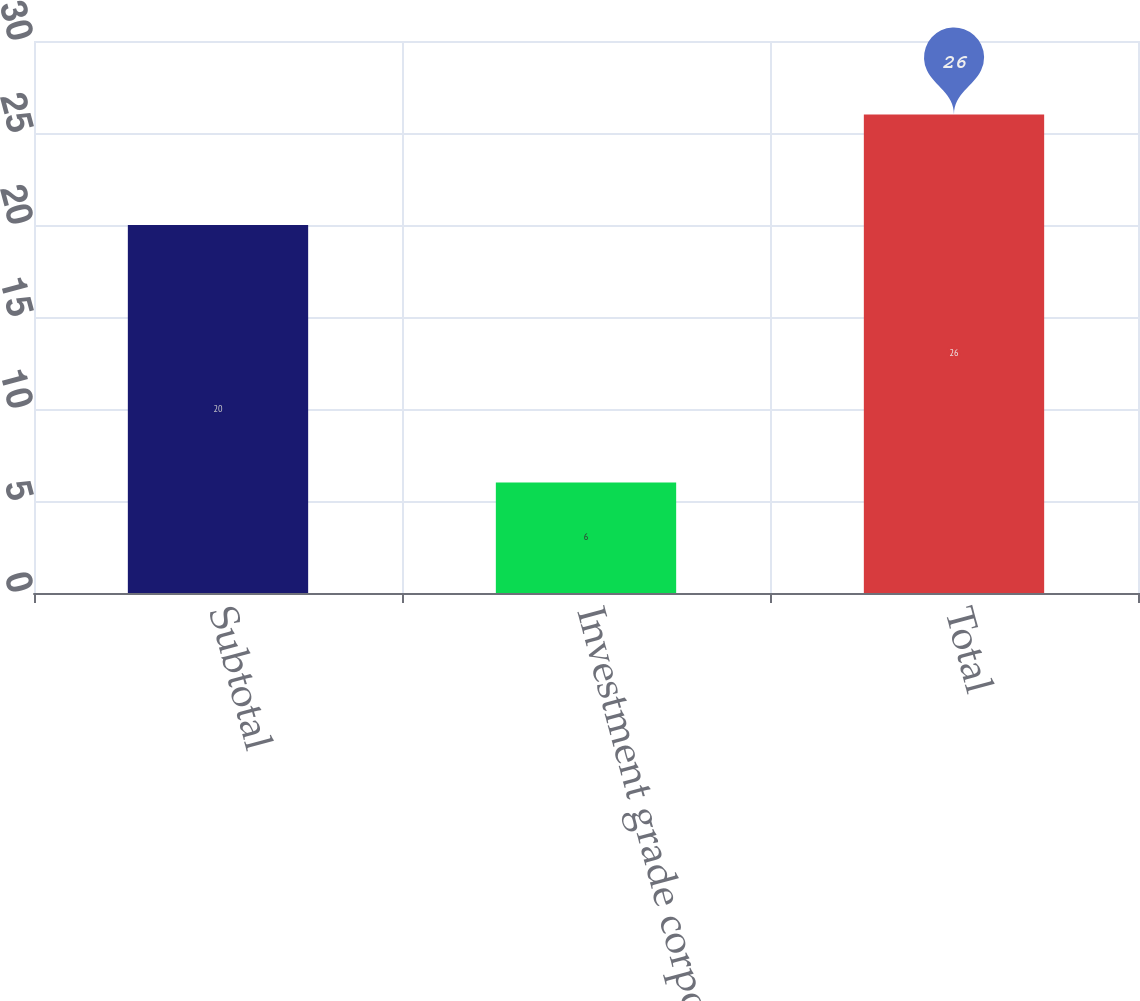Convert chart. <chart><loc_0><loc_0><loc_500><loc_500><bar_chart><fcel>Subtotal<fcel>Investment grade corporate<fcel>Total<nl><fcel>20<fcel>6<fcel>26<nl></chart> 